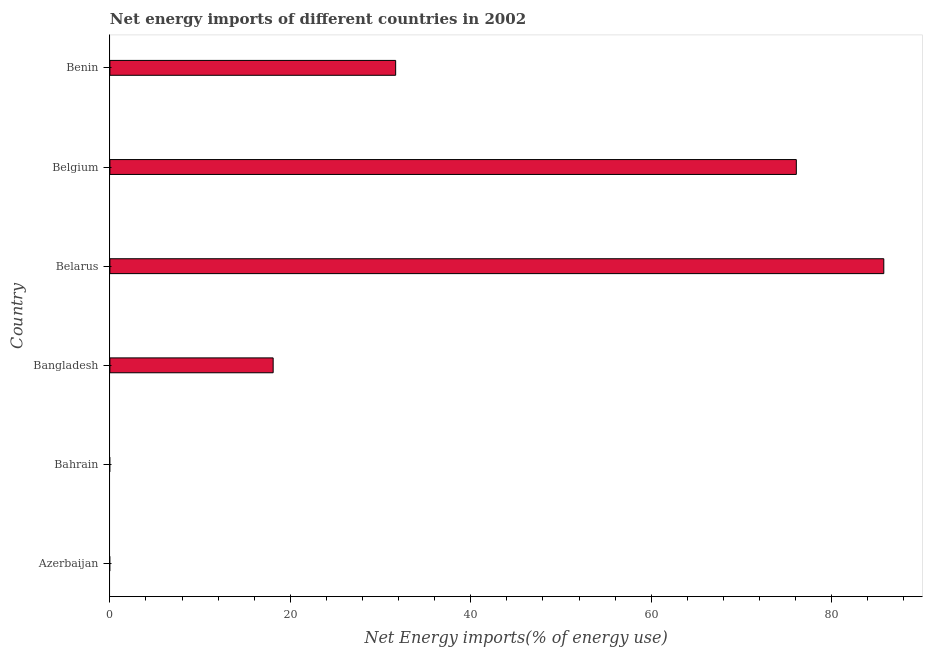Does the graph contain grids?
Make the answer very short. No. What is the title of the graph?
Provide a succinct answer. Net energy imports of different countries in 2002. What is the label or title of the X-axis?
Your response must be concise. Net Energy imports(% of energy use). What is the label or title of the Y-axis?
Your answer should be very brief. Country. Across all countries, what is the maximum energy imports?
Make the answer very short. 85.78. In which country was the energy imports maximum?
Provide a short and direct response. Belarus. What is the sum of the energy imports?
Your answer should be compact. 211.63. What is the difference between the energy imports in Belgium and Benin?
Your answer should be compact. 44.41. What is the average energy imports per country?
Give a very brief answer. 35.27. What is the median energy imports?
Your answer should be compact. 24.89. In how many countries, is the energy imports greater than 72 %?
Make the answer very short. 2. What is the ratio of the energy imports in Belarus to that in Belgium?
Give a very brief answer. 1.13. Is the energy imports in Bangladesh less than that in Belgium?
Your answer should be compact. Yes. Is the difference between the energy imports in Bangladesh and Belarus greater than the difference between any two countries?
Offer a terse response. No. What is the difference between the highest and the second highest energy imports?
Provide a short and direct response. 9.7. What is the difference between the highest and the lowest energy imports?
Make the answer very short. 85.78. How many bars are there?
Make the answer very short. 4. How many countries are there in the graph?
Make the answer very short. 6. What is the difference between two consecutive major ticks on the X-axis?
Ensure brevity in your answer.  20. Are the values on the major ticks of X-axis written in scientific E-notation?
Provide a succinct answer. No. What is the Net Energy imports(% of energy use) in Bahrain?
Offer a very short reply. 0. What is the Net Energy imports(% of energy use) of Bangladesh?
Offer a terse response. 18.1. What is the Net Energy imports(% of energy use) in Belarus?
Provide a short and direct response. 85.78. What is the Net Energy imports(% of energy use) of Belgium?
Your response must be concise. 76.08. What is the Net Energy imports(% of energy use) in Benin?
Ensure brevity in your answer.  31.67. What is the difference between the Net Energy imports(% of energy use) in Bangladesh and Belarus?
Keep it short and to the point. -67.68. What is the difference between the Net Energy imports(% of energy use) in Bangladesh and Belgium?
Offer a terse response. -57.99. What is the difference between the Net Energy imports(% of energy use) in Bangladesh and Benin?
Keep it short and to the point. -13.58. What is the difference between the Net Energy imports(% of energy use) in Belarus and Belgium?
Offer a very short reply. 9.69. What is the difference between the Net Energy imports(% of energy use) in Belarus and Benin?
Make the answer very short. 54.1. What is the difference between the Net Energy imports(% of energy use) in Belgium and Benin?
Ensure brevity in your answer.  44.41. What is the ratio of the Net Energy imports(% of energy use) in Bangladesh to that in Belarus?
Offer a terse response. 0.21. What is the ratio of the Net Energy imports(% of energy use) in Bangladesh to that in Belgium?
Keep it short and to the point. 0.24. What is the ratio of the Net Energy imports(% of energy use) in Bangladesh to that in Benin?
Ensure brevity in your answer.  0.57. What is the ratio of the Net Energy imports(% of energy use) in Belarus to that in Belgium?
Your response must be concise. 1.13. What is the ratio of the Net Energy imports(% of energy use) in Belarus to that in Benin?
Provide a succinct answer. 2.71. What is the ratio of the Net Energy imports(% of energy use) in Belgium to that in Benin?
Provide a succinct answer. 2.4. 